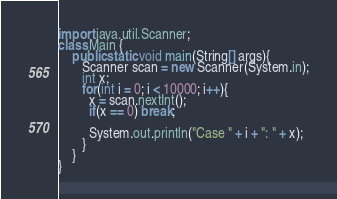Convert code to text. <code><loc_0><loc_0><loc_500><loc_500><_Java_>import java.util.Scanner;
class Main {
    public static void main(String[] args){
       Scanner scan = new Scanner(System.in);
       int x;
       for(int i = 0; i < 10000; i++){
         x = scan.nextInt();
         if(x == 0) break;

         System.out.println("Case " + i + ": " + x);
       }
    }
}</code> 